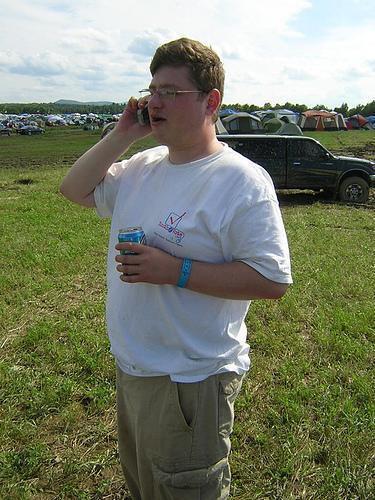What is his hairstyle?
Pick the right solution, then justify: 'Answer: answer
Rationale: rationale.'
Options: Short, long, curly, shaved. Answer: long.
Rationale: Haircut lengths are subjective however in today many consider the shaven head as being short.  the man in the photo has reasonable amount of hair and would thus be considered long. Where will people located here sleep tonight?
Choose the right answer from the provided options to respond to the question.
Options: No where, tents, limos, duplexes. Tents. 